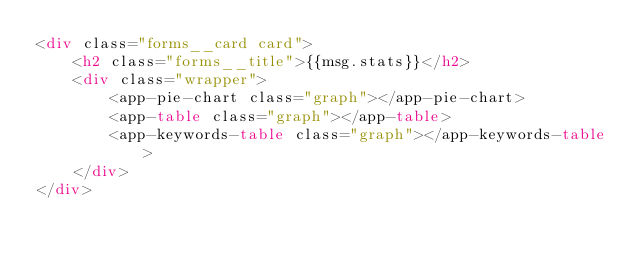Convert code to text. <code><loc_0><loc_0><loc_500><loc_500><_HTML_><div class="forms__card card">
    <h2 class="forms__title">{{msg.stats}}</h2>
    <div class="wrapper">
        <app-pie-chart class="graph"></app-pie-chart>
        <app-table class="graph"></app-table>
        <app-keywords-table class="graph"></app-keywords-table>
    </div>
</div>
</code> 